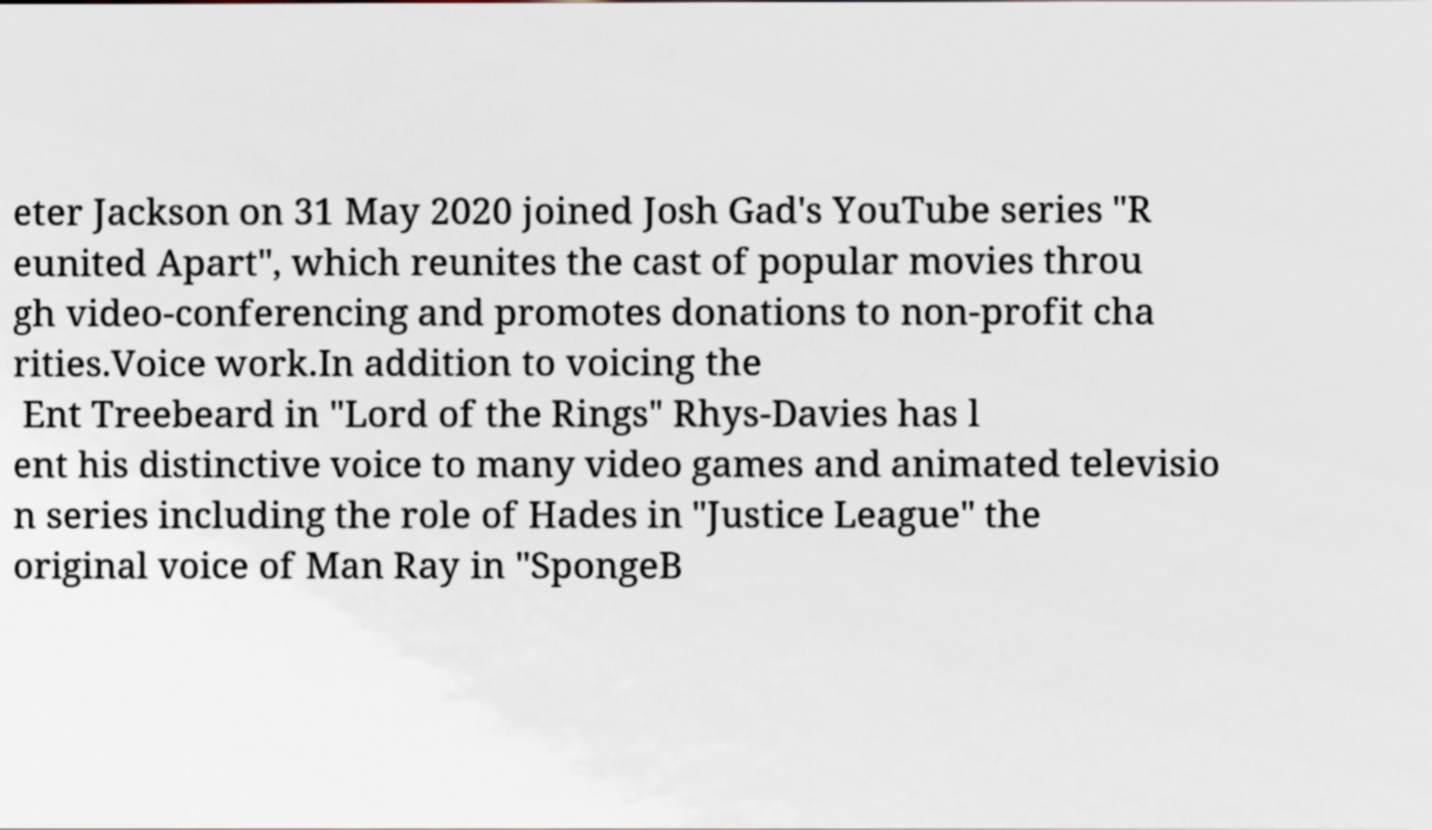For documentation purposes, I need the text within this image transcribed. Could you provide that? eter Jackson on 31 May 2020 joined Josh Gad's YouTube series "R eunited Apart", which reunites the cast of popular movies throu gh video-conferencing and promotes donations to non-profit cha rities.Voice work.In addition to voicing the Ent Treebeard in "Lord of the Rings" Rhys-Davies has l ent his distinctive voice to many video games and animated televisio n series including the role of Hades in "Justice League" the original voice of Man Ray in "SpongeB 